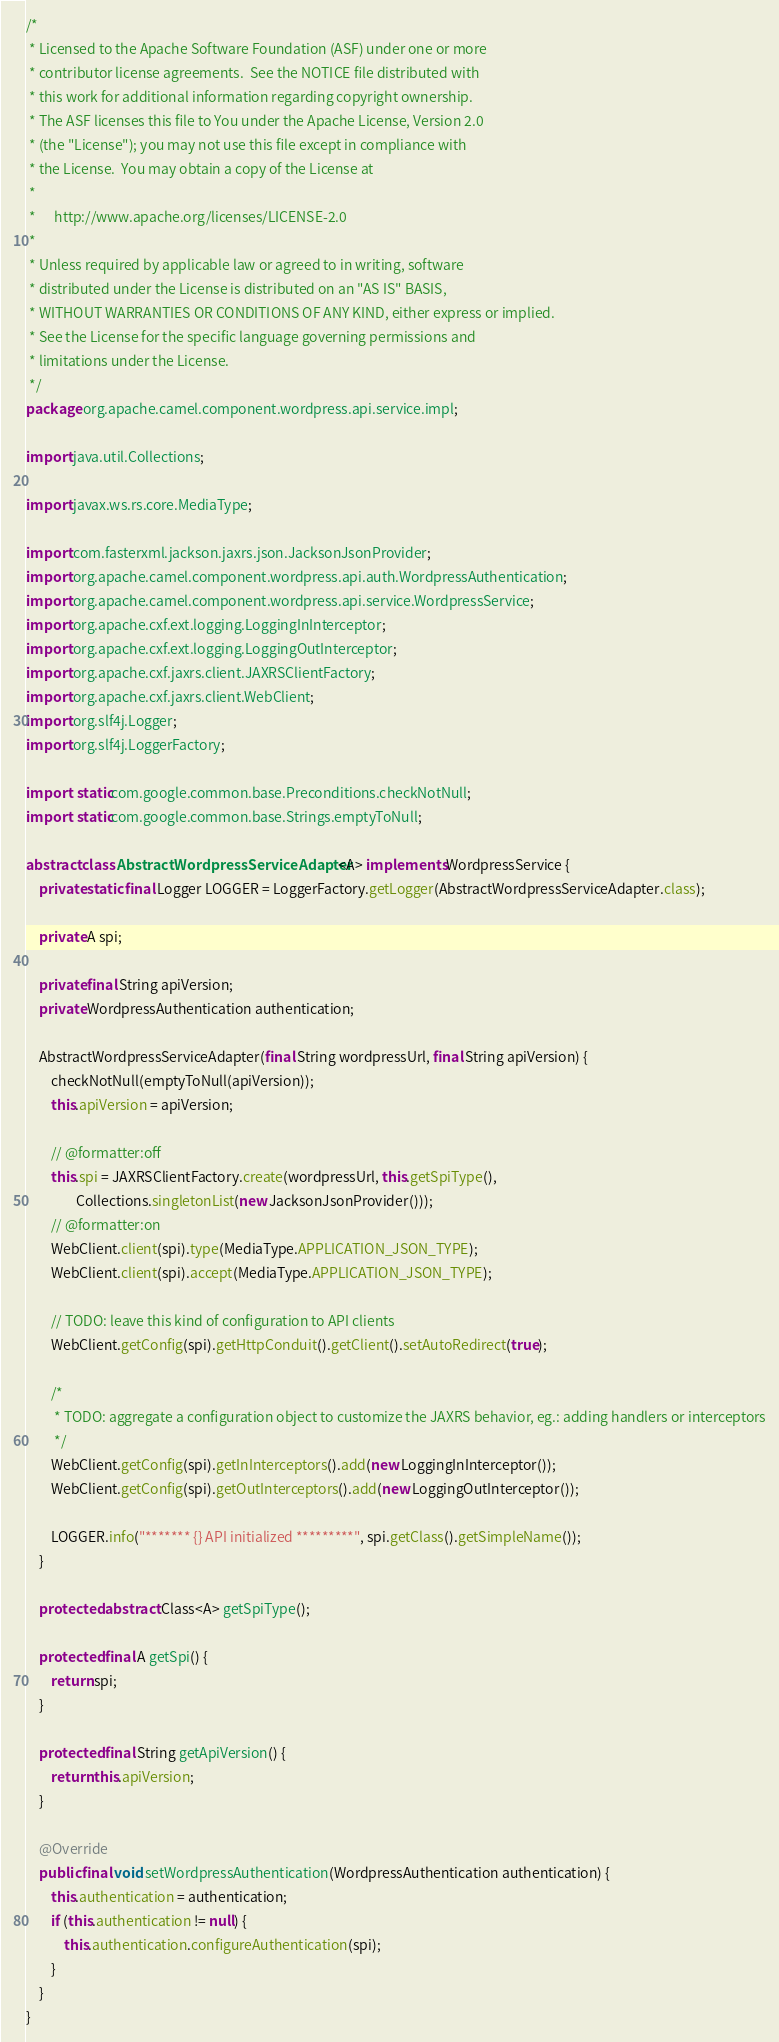<code> <loc_0><loc_0><loc_500><loc_500><_Java_>/*
 * Licensed to the Apache Software Foundation (ASF) under one or more
 * contributor license agreements.  See the NOTICE file distributed with
 * this work for additional information regarding copyright ownership.
 * The ASF licenses this file to You under the Apache License, Version 2.0
 * (the "License"); you may not use this file except in compliance with
 * the License.  You may obtain a copy of the License at
 *
 *      http://www.apache.org/licenses/LICENSE-2.0
 *
 * Unless required by applicable law or agreed to in writing, software
 * distributed under the License is distributed on an "AS IS" BASIS,
 * WITHOUT WARRANTIES OR CONDITIONS OF ANY KIND, either express or implied.
 * See the License for the specific language governing permissions and
 * limitations under the License.
 */
package org.apache.camel.component.wordpress.api.service.impl;

import java.util.Collections;

import javax.ws.rs.core.MediaType;

import com.fasterxml.jackson.jaxrs.json.JacksonJsonProvider;
import org.apache.camel.component.wordpress.api.auth.WordpressAuthentication;
import org.apache.camel.component.wordpress.api.service.WordpressService;
import org.apache.cxf.ext.logging.LoggingInInterceptor;
import org.apache.cxf.ext.logging.LoggingOutInterceptor;
import org.apache.cxf.jaxrs.client.JAXRSClientFactory;
import org.apache.cxf.jaxrs.client.WebClient;
import org.slf4j.Logger;
import org.slf4j.LoggerFactory;

import static com.google.common.base.Preconditions.checkNotNull;
import static com.google.common.base.Strings.emptyToNull;

abstract class AbstractWordpressServiceAdapter<A> implements WordpressService {
    private static final Logger LOGGER = LoggerFactory.getLogger(AbstractWordpressServiceAdapter.class);

    private A spi;

    private final String apiVersion;
    private WordpressAuthentication authentication;

    AbstractWordpressServiceAdapter(final String wordpressUrl, final String apiVersion) {
        checkNotNull(emptyToNull(apiVersion));
        this.apiVersion = apiVersion;

        // @formatter:off
        this.spi = JAXRSClientFactory.create(wordpressUrl, this.getSpiType(),
                Collections.singletonList(new JacksonJsonProvider()));
        // @formatter:on
        WebClient.client(spi).type(MediaType.APPLICATION_JSON_TYPE);
        WebClient.client(spi).accept(MediaType.APPLICATION_JSON_TYPE);

        // TODO: leave this kind of configuration to API clients
        WebClient.getConfig(spi).getHttpConduit().getClient().setAutoRedirect(true);

        /*
         * TODO: aggregate a configuration object to customize the JAXRS behavior, eg.: adding handlers or interceptors
         */
        WebClient.getConfig(spi).getInInterceptors().add(new LoggingInInterceptor());
        WebClient.getConfig(spi).getOutInterceptors().add(new LoggingOutInterceptor());

        LOGGER.info("******* {} API initialized *********", spi.getClass().getSimpleName());
    }

    protected abstract Class<A> getSpiType();

    protected final A getSpi() {
        return spi;
    }

    protected final String getApiVersion() {
        return this.apiVersion;
    }

    @Override
    public final void setWordpressAuthentication(WordpressAuthentication authentication) {
        this.authentication = authentication;
        if (this.authentication != null) {
            this.authentication.configureAuthentication(spi);
        }
    }
}
</code> 